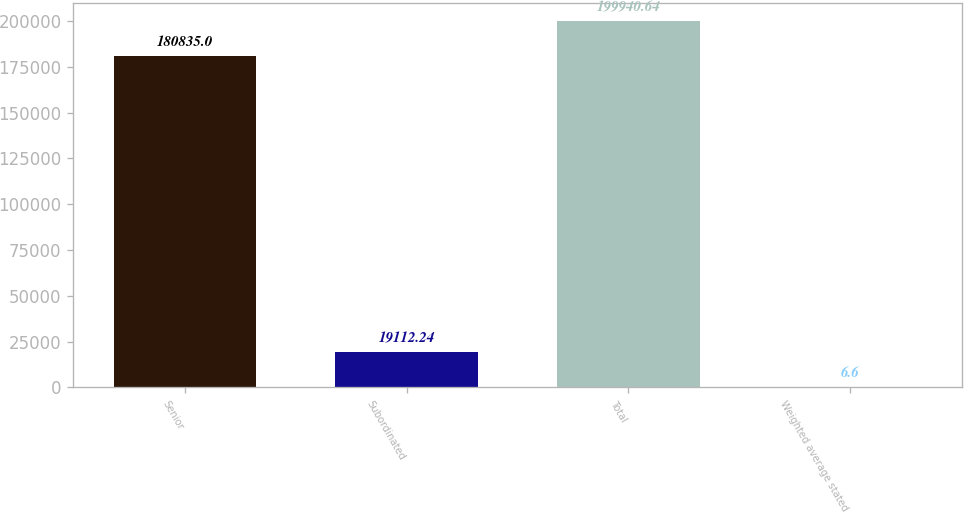Convert chart. <chart><loc_0><loc_0><loc_500><loc_500><bar_chart><fcel>Senior<fcel>Subordinated<fcel>Total<fcel>Weighted average stated<nl><fcel>180835<fcel>19112.2<fcel>199941<fcel>6.6<nl></chart> 